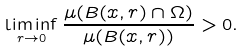Convert formula to latex. <formula><loc_0><loc_0><loc_500><loc_500>\liminf _ { r \to 0 } \frac { \mu ( B ( x , r ) \cap \Omega ) } { \mu ( B ( x , r ) ) } > 0 .</formula> 